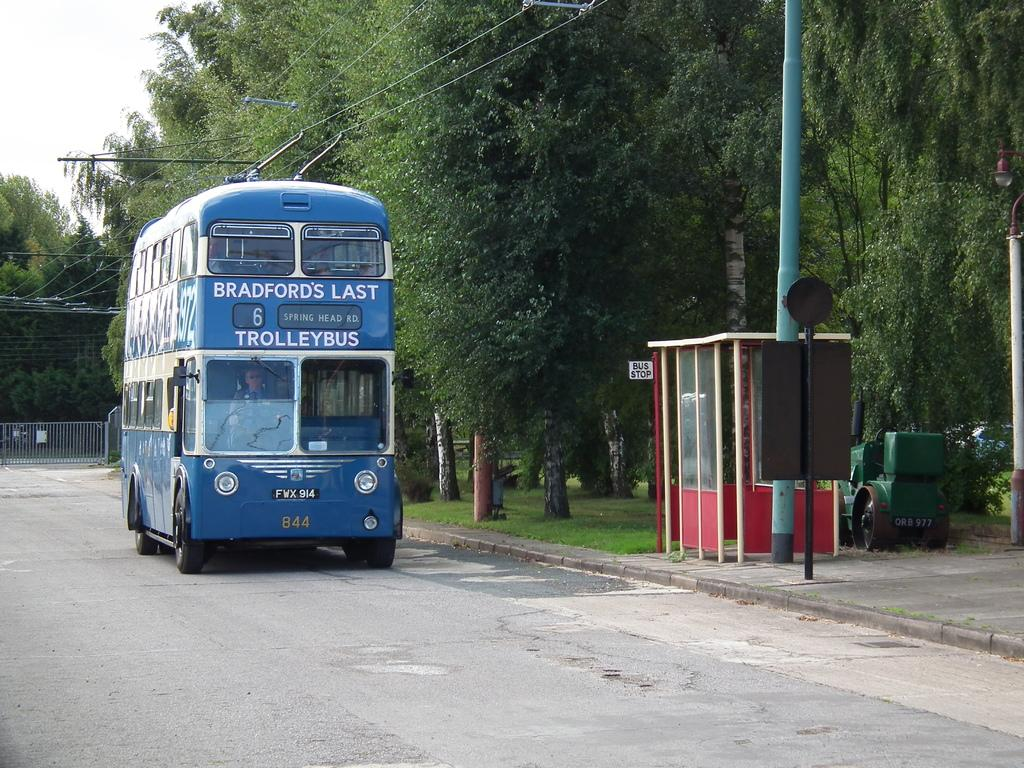<image>
Provide a brief description of the given image. Blue double decker bus which says Trolleybus on it. 